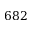<formula> <loc_0><loc_0><loc_500><loc_500>6 8 2</formula> 